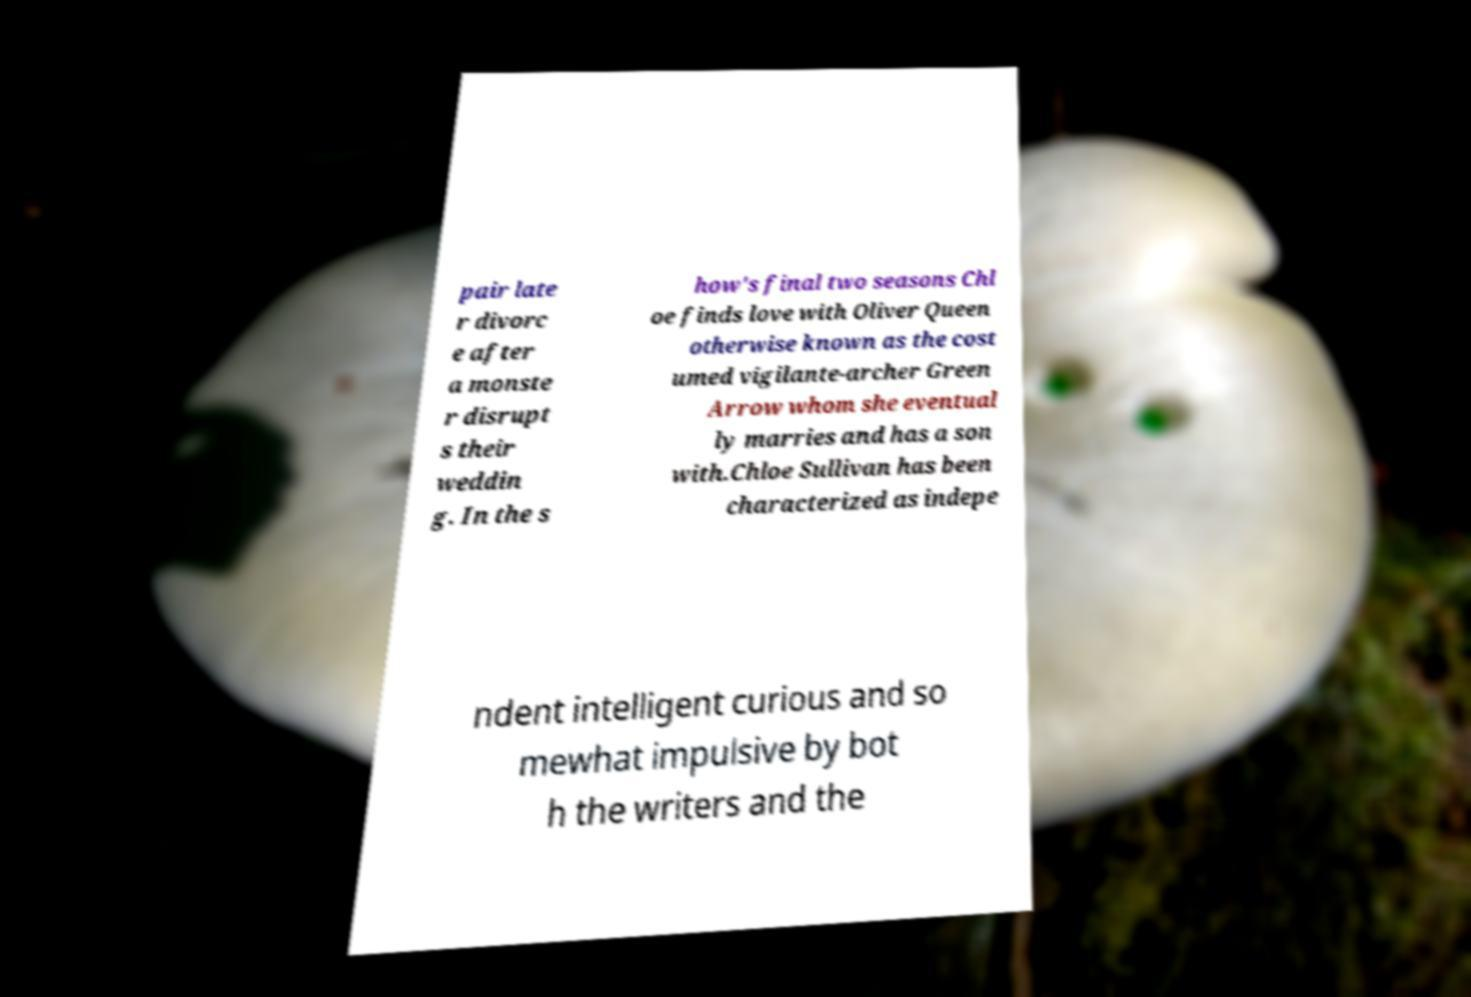Can you accurately transcribe the text from the provided image for me? pair late r divorc e after a monste r disrupt s their weddin g. In the s how's final two seasons Chl oe finds love with Oliver Queen otherwise known as the cost umed vigilante-archer Green Arrow whom she eventual ly marries and has a son with.Chloe Sullivan has been characterized as indepe ndent intelligent curious and so mewhat impulsive by bot h the writers and the 